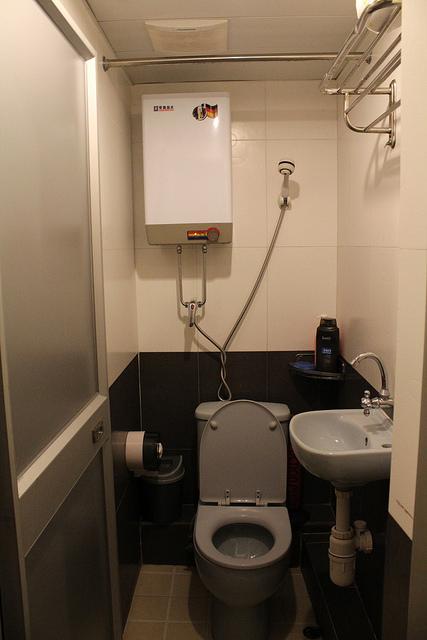What color is the toilet?
Short answer required. Gray. Is this a public bathroom?
Concise answer only. Yes. Where is the toilet's handle?
Quick response, please. On wall. Does the toilet seat cover match the color of the walls?
Keep it brief. No. Is the lid up?
Give a very brief answer. Yes. What is one clue that this is not a private home?
Answer briefly. Toilet. Yes the lid is up?
Give a very brief answer. Yes. Is this toilet flushed?
Concise answer only. Yes. Does a man use this restroom?
Concise answer only. Yes. 